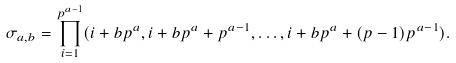<formula> <loc_0><loc_0><loc_500><loc_500>\sigma _ { a , b } = \prod _ { i = 1 } ^ { p ^ { a - 1 } } ( i + b p ^ { a } , i + b p ^ { a } + p ^ { a - 1 } , \dots , i + b p ^ { a } + ( p - 1 ) p ^ { a - 1 } ) .</formula> 